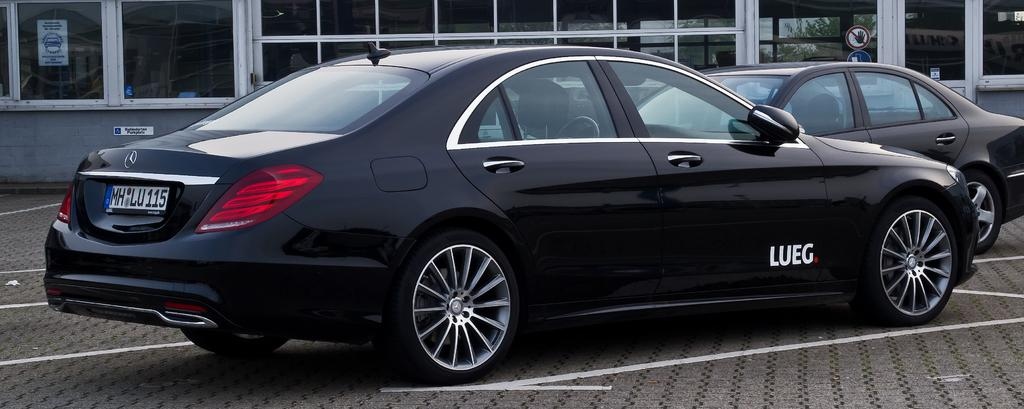How many cars are visible in the image? There are two black cars in the image. What type of structure can be seen in the image? There is a building in the image. Can you describe the poster in the image? There is a poster on a glass surface with some text. What type of wood is the monkey holding in the image? There is no monkey or wood present in the image. Can you describe the bone structure of the creature in the image? There is no creature or bone structure present in the image. 